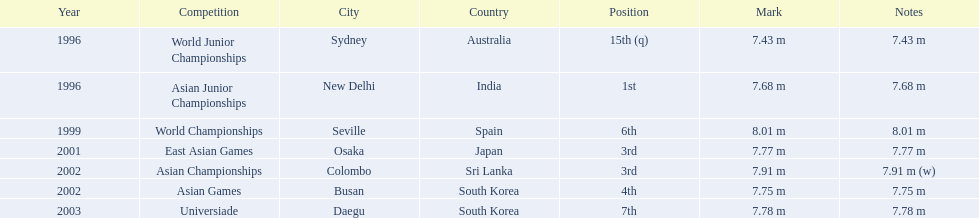How many competitions did he place in the top three? 3. 